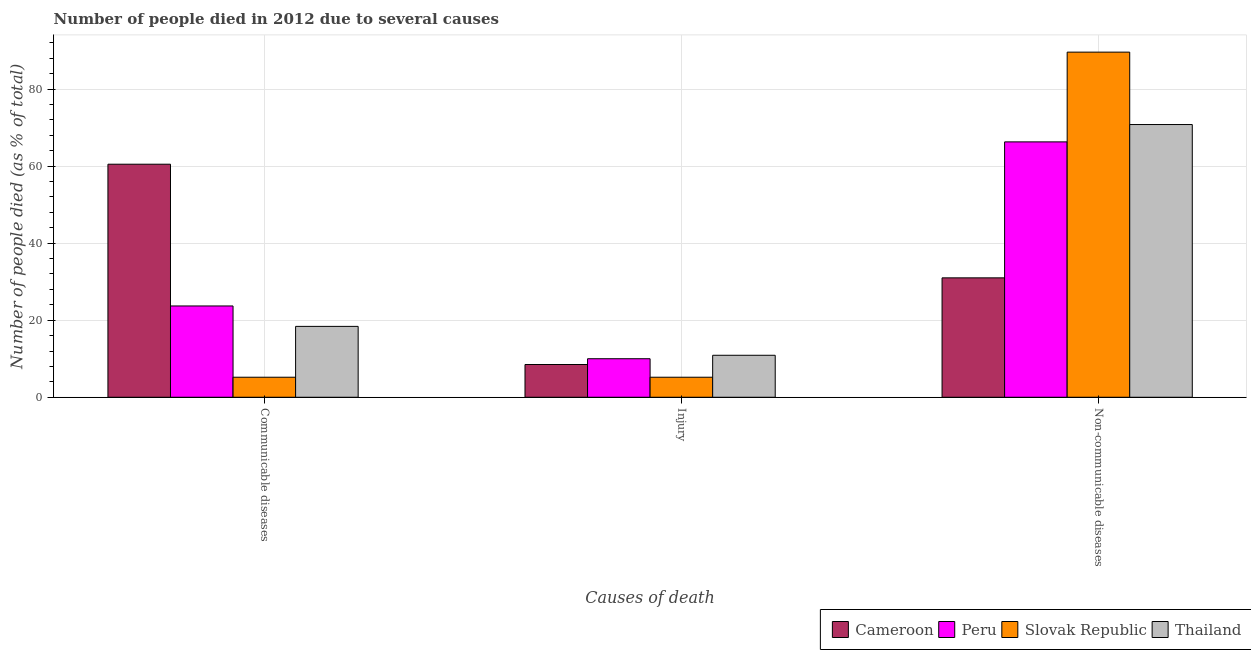How many groups of bars are there?
Offer a terse response. 3. Are the number of bars per tick equal to the number of legend labels?
Offer a terse response. Yes. How many bars are there on the 1st tick from the right?
Offer a terse response. 4. What is the label of the 3rd group of bars from the left?
Your answer should be very brief. Non-communicable diseases. What is the number of people who died of injury in Cameroon?
Keep it short and to the point. 8.5. Across all countries, what is the maximum number of people who dies of non-communicable diseases?
Make the answer very short. 89.6. In which country was the number of people who died of communicable diseases maximum?
Your answer should be very brief. Cameroon. In which country was the number of people who died of injury minimum?
Your answer should be very brief. Slovak Republic. What is the total number of people who died of communicable diseases in the graph?
Give a very brief answer. 107.8. What is the difference between the number of people who died of communicable diseases in Thailand and that in Peru?
Offer a terse response. -5.3. What is the difference between the number of people who dies of non-communicable diseases in Cameroon and the number of people who died of injury in Slovak Republic?
Ensure brevity in your answer.  25.8. What is the average number of people who died of communicable diseases per country?
Ensure brevity in your answer.  26.95. What is the ratio of the number of people who died of communicable diseases in Cameroon to that in Slovak Republic?
Offer a very short reply. 11.63. Is the number of people who died of injury in Slovak Republic less than that in Peru?
Keep it short and to the point. Yes. What is the difference between the highest and the second highest number of people who died of communicable diseases?
Keep it short and to the point. 36.8. In how many countries, is the number of people who dies of non-communicable diseases greater than the average number of people who dies of non-communicable diseases taken over all countries?
Give a very brief answer. 3. Is the sum of the number of people who dies of non-communicable diseases in Peru and Cameroon greater than the maximum number of people who died of injury across all countries?
Offer a very short reply. Yes. What does the 4th bar from the left in Injury represents?
Ensure brevity in your answer.  Thailand. What does the 2nd bar from the right in Non-communicable diseases represents?
Offer a very short reply. Slovak Republic. Is it the case that in every country, the sum of the number of people who died of communicable diseases and number of people who died of injury is greater than the number of people who dies of non-communicable diseases?
Provide a succinct answer. No. How many bars are there?
Keep it short and to the point. 12. What is the difference between two consecutive major ticks on the Y-axis?
Make the answer very short. 20. Are the values on the major ticks of Y-axis written in scientific E-notation?
Offer a very short reply. No. Does the graph contain any zero values?
Offer a very short reply. No. Does the graph contain grids?
Offer a terse response. Yes. Where does the legend appear in the graph?
Your answer should be compact. Bottom right. How are the legend labels stacked?
Your answer should be compact. Horizontal. What is the title of the graph?
Your answer should be compact. Number of people died in 2012 due to several causes. Does "Switzerland" appear as one of the legend labels in the graph?
Give a very brief answer. No. What is the label or title of the X-axis?
Keep it short and to the point. Causes of death. What is the label or title of the Y-axis?
Your answer should be compact. Number of people died (as % of total). What is the Number of people died (as % of total) in Cameroon in Communicable diseases?
Offer a very short reply. 60.5. What is the Number of people died (as % of total) of Peru in Communicable diseases?
Keep it short and to the point. 23.7. What is the Number of people died (as % of total) in Peru in Injury?
Offer a terse response. 10. What is the Number of people died (as % of total) in Cameroon in Non-communicable diseases?
Offer a very short reply. 31. What is the Number of people died (as % of total) of Peru in Non-communicable diseases?
Offer a very short reply. 66.3. What is the Number of people died (as % of total) in Slovak Republic in Non-communicable diseases?
Offer a terse response. 89.6. What is the Number of people died (as % of total) of Thailand in Non-communicable diseases?
Provide a short and direct response. 70.8. Across all Causes of death, what is the maximum Number of people died (as % of total) of Cameroon?
Make the answer very short. 60.5. Across all Causes of death, what is the maximum Number of people died (as % of total) in Peru?
Provide a succinct answer. 66.3. Across all Causes of death, what is the maximum Number of people died (as % of total) of Slovak Republic?
Offer a terse response. 89.6. Across all Causes of death, what is the maximum Number of people died (as % of total) of Thailand?
Ensure brevity in your answer.  70.8. Across all Causes of death, what is the minimum Number of people died (as % of total) in Peru?
Keep it short and to the point. 10. What is the total Number of people died (as % of total) in Cameroon in the graph?
Provide a short and direct response. 100. What is the total Number of people died (as % of total) of Peru in the graph?
Your answer should be very brief. 100. What is the total Number of people died (as % of total) in Slovak Republic in the graph?
Make the answer very short. 100. What is the total Number of people died (as % of total) in Thailand in the graph?
Make the answer very short. 100.1. What is the difference between the Number of people died (as % of total) in Cameroon in Communicable diseases and that in Injury?
Offer a terse response. 52. What is the difference between the Number of people died (as % of total) in Slovak Republic in Communicable diseases and that in Injury?
Your answer should be very brief. 0. What is the difference between the Number of people died (as % of total) in Thailand in Communicable diseases and that in Injury?
Keep it short and to the point. 7.5. What is the difference between the Number of people died (as % of total) of Cameroon in Communicable diseases and that in Non-communicable diseases?
Your answer should be compact. 29.5. What is the difference between the Number of people died (as % of total) in Peru in Communicable diseases and that in Non-communicable diseases?
Your answer should be compact. -42.6. What is the difference between the Number of people died (as % of total) of Slovak Republic in Communicable diseases and that in Non-communicable diseases?
Make the answer very short. -84.4. What is the difference between the Number of people died (as % of total) of Thailand in Communicable diseases and that in Non-communicable diseases?
Provide a short and direct response. -52.4. What is the difference between the Number of people died (as % of total) in Cameroon in Injury and that in Non-communicable diseases?
Offer a very short reply. -22.5. What is the difference between the Number of people died (as % of total) of Peru in Injury and that in Non-communicable diseases?
Offer a very short reply. -56.3. What is the difference between the Number of people died (as % of total) in Slovak Republic in Injury and that in Non-communicable diseases?
Provide a short and direct response. -84.4. What is the difference between the Number of people died (as % of total) in Thailand in Injury and that in Non-communicable diseases?
Your response must be concise. -59.9. What is the difference between the Number of people died (as % of total) of Cameroon in Communicable diseases and the Number of people died (as % of total) of Peru in Injury?
Ensure brevity in your answer.  50.5. What is the difference between the Number of people died (as % of total) of Cameroon in Communicable diseases and the Number of people died (as % of total) of Slovak Republic in Injury?
Give a very brief answer. 55.3. What is the difference between the Number of people died (as % of total) of Cameroon in Communicable diseases and the Number of people died (as % of total) of Thailand in Injury?
Keep it short and to the point. 49.6. What is the difference between the Number of people died (as % of total) of Peru in Communicable diseases and the Number of people died (as % of total) of Slovak Republic in Injury?
Your response must be concise. 18.5. What is the difference between the Number of people died (as % of total) in Peru in Communicable diseases and the Number of people died (as % of total) in Thailand in Injury?
Offer a very short reply. 12.8. What is the difference between the Number of people died (as % of total) of Slovak Republic in Communicable diseases and the Number of people died (as % of total) of Thailand in Injury?
Your response must be concise. -5.7. What is the difference between the Number of people died (as % of total) in Cameroon in Communicable diseases and the Number of people died (as % of total) in Peru in Non-communicable diseases?
Keep it short and to the point. -5.8. What is the difference between the Number of people died (as % of total) of Cameroon in Communicable diseases and the Number of people died (as % of total) of Slovak Republic in Non-communicable diseases?
Offer a terse response. -29.1. What is the difference between the Number of people died (as % of total) of Peru in Communicable diseases and the Number of people died (as % of total) of Slovak Republic in Non-communicable diseases?
Ensure brevity in your answer.  -65.9. What is the difference between the Number of people died (as % of total) of Peru in Communicable diseases and the Number of people died (as % of total) of Thailand in Non-communicable diseases?
Keep it short and to the point. -47.1. What is the difference between the Number of people died (as % of total) of Slovak Republic in Communicable diseases and the Number of people died (as % of total) of Thailand in Non-communicable diseases?
Your answer should be very brief. -65.6. What is the difference between the Number of people died (as % of total) of Cameroon in Injury and the Number of people died (as % of total) of Peru in Non-communicable diseases?
Your response must be concise. -57.8. What is the difference between the Number of people died (as % of total) in Cameroon in Injury and the Number of people died (as % of total) in Slovak Republic in Non-communicable diseases?
Provide a short and direct response. -81.1. What is the difference between the Number of people died (as % of total) of Cameroon in Injury and the Number of people died (as % of total) of Thailand in Non-communicable diseases?
Make the answer very short. -62.3. What is the difference between the Number of people died (as % of total) of Peru in Injury and the Number of people died (as % of total) of Slovak Republic in Non-communicable diseases?
Give a very brief answer. -79.6. What is the difference between the Number of people died (as % of total) of Peru in Injury and the Number of people died (as % of total) of Thailand in Non-communicable diseases?
Provide a succinct answer. -60.8. What is the difference between the Number of people died (as % of total) of Slovak Republic in Injury and the Number of people died (as % of total) of Thailand in Non-communicable diseases?
Make the answer very short. -65.6. What is the average Number of people died (as % of total) in Cameroon per Causes of death?
Your answer should be very brief. 33.33. What is the average Number of people died (as % of total) in Peru per Causes of death?
Ensure brevity in your answer.  33.33. What is the average Number of people died (as % of total) of Slovak Republic per Causes of death?
Your response must be concise. 33.33. What is the average Number of people died (as % of total) in Thailand per Causes of death?
Give a very brief answer. 33.37. What is the difference between the Number of people died (as % of total) in Cameroon and Number of people died (as % of total) in Peru in Communicable diseases?
Provide a short and direct response. 36.8. What is the difference between the Number of people died (as % of total) in Cameroon and Number of people died (as % of total) in Slovak Republic in Communicable diseases?
Offer a very short reply. 55.3. What is the difference between the Number of people died (as % of total) of Cameroon and Number of people died (as % of total) of Thailand in Communicable diseases?
Offer a terse response. 42.1. What is the difference between the Number of people died (as % of total) of Peru and Number of people died (as % of total) of Slovak Republic in Communicable diseases?
Offer a terse response. 18.5. What is the difference between the Number of people died (as % of total) in Cameroon and Number of people died (as % of total) in Peru in Injury?
Provide a succinct answer. -1.5. What is the difference between the Number of people died (as % of total) in Cameroon and Number of people died (as % of total) in Slovak Republic in Injury?
Provide a succinct answer. 3.3. What is the difference between the Number of people died (as % of total) of Cameroon and Number of people died (as % of total) of Thailand in Injury?
Offer a terse response. -2.4. What is the difference between the Number of people died (as % of total) in Peru and Number of people died (as % of total) in Slovak Republic in Injury?
Provide a succinct answer. 4.8. What is the difference between the Number of people died (as % of total) in Slovak Republic and Number of people died (as % of total) in Thailand in Injury?
Your response must be concise. -5.7. What is the difference between the Number of people died (as % of total) in Cameroon and Number of people died (as % of total) in Peru in Non-communicable diseases?
Offer a terse response. -35.3. What is the difference between the Number of people died (as % of total) of Cameroon and Number of people died (as % of total) of Slovak Republic in Non-communicable diseases?
Offer a terse response. -58.6. What is the difference between the Number of people died (as % of total) in Cameroon and Number of people died (as % of total) in Thailand in Non-communicable diseases?
Your answer should be very brief. -39.8. What is the difference between the Number of people died (as % of total) in Peru and Number of people died (as % of total) in Slovak Republic in Non-communicable diseases?
Keep it short and to the point. -23.3. What is the difference between the Number of people died (as % of total) of Peru and Number of people died (as % of total) of Thailand in Non-communicable diseases?
Your answer should be compact. -4.5. What is the difference between the Number of people died (as % of total) of Slovak Republic and Number of people died (as % of total) of Thailand in Non-communicable diseases?
Make the answer very short. 18.8. What is the ratio of the Number of people died (as % of total) of Cameroon in Communicable diseases to that in Injury?
Make the answer very short. 7.12. What is the ratio of the Number of people died (as % of total) in Peru in Communicable diseases to that in Injury?
Your answer should be very brief. 2.37. What is the ratio of the Number of people died (as % of total) of Thailand in Communicable diseases to that in Injury?
Make the answer very short. 1.69. What is the ratio of the Number of people died (as % of total) in Cameroon in Communicable diseases to that in Non-communicable diseases?
Provide a succinct answer. 1.95. What is the ratio of the Number of people died (as % of total) in Peru in Communicable diseases to that in Non-communicable diseases?
Offer a very short reply. 0.36. What is the ratio of the Number of people died (as % of total) in Slovak Republic in Communicable diseases to that in Non-communicable diseases?
Offer a very short reply. 0.06. What is the ratio of the Number of people died (as % of total) in Thailand in Communicable diseases to that in Non-communicable diseases?
Your answer should be compact. 0.26. What is the ratio of the Number of people died (as % of total) in Cameroon in Injury to that in Non-communicable diseases?
Provide a succinct answer. 0.27. What is the ratio of the Number of people died (as % of total) of Peru in Injury to that in Non-communicable diseases?
Keep it short and to the point. 0.15. What is the ratio of the Number of people died (as % of total) in Slovak Republic in Injury to that in Non-communicable diseases?
Offer a terse response. 0.06. What is the ratio of the Number of people died (as % of total) of Thailand in Injury to that in Non-communicable diseases?
Provide a succinct answer. 0.15. What is the difference between the highest and the second highest Number of people died (as % of total) in Cameroon?
Your response must be concise. 29.5. What is the difference between the highest and the second highest Number of people died (as % of total) in Peru?
Your response must be concise. 42.6. What is the difference between the highest and the second highest Number of people died (as % of total) in Slovak Republic?
Ensure brevity in your answer.  84.4. What is the difference between the highest and the second highest Number of people died (as % of total) in Thailand?
Your response must be concise. 52.4. What is the difference between the highest and the lowest Number of people died (as % of total) of Cameroon?
Keep it short and to the point. 52. What is the difference between the highest and the lowest Number of people died (as % of total) in Peru?
Keep it short and to the point. 56.3. What is the difference between the highest and the lowest Number of people died (as % of total) of Slovak Republic?
Your response must be concise. 84.4. What is the difference between the highest and the lowest Number of people died (as % of total) in Thailand?
Your answer should be compact. 59.9. 